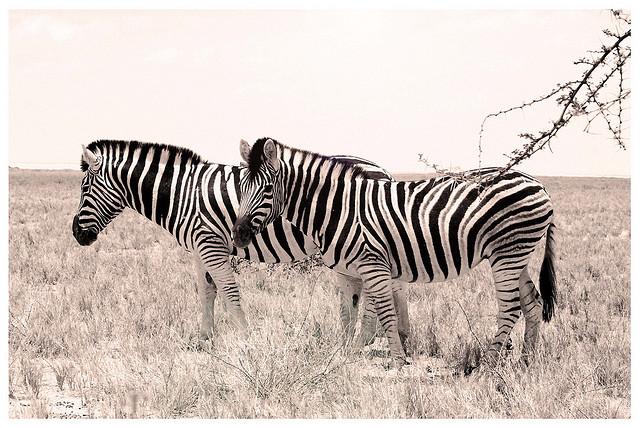Are both zebras facing the same direction?
Answer briefly. Yes. Are these zebras charging one another?
Short answer required. No. What kind of temperatures are these animals used to?
Give a very brief answer. Hot. Are these animals in captivity?
Write a very short answer. No. How many zebras are in the photo?
Short answer required. 2. 